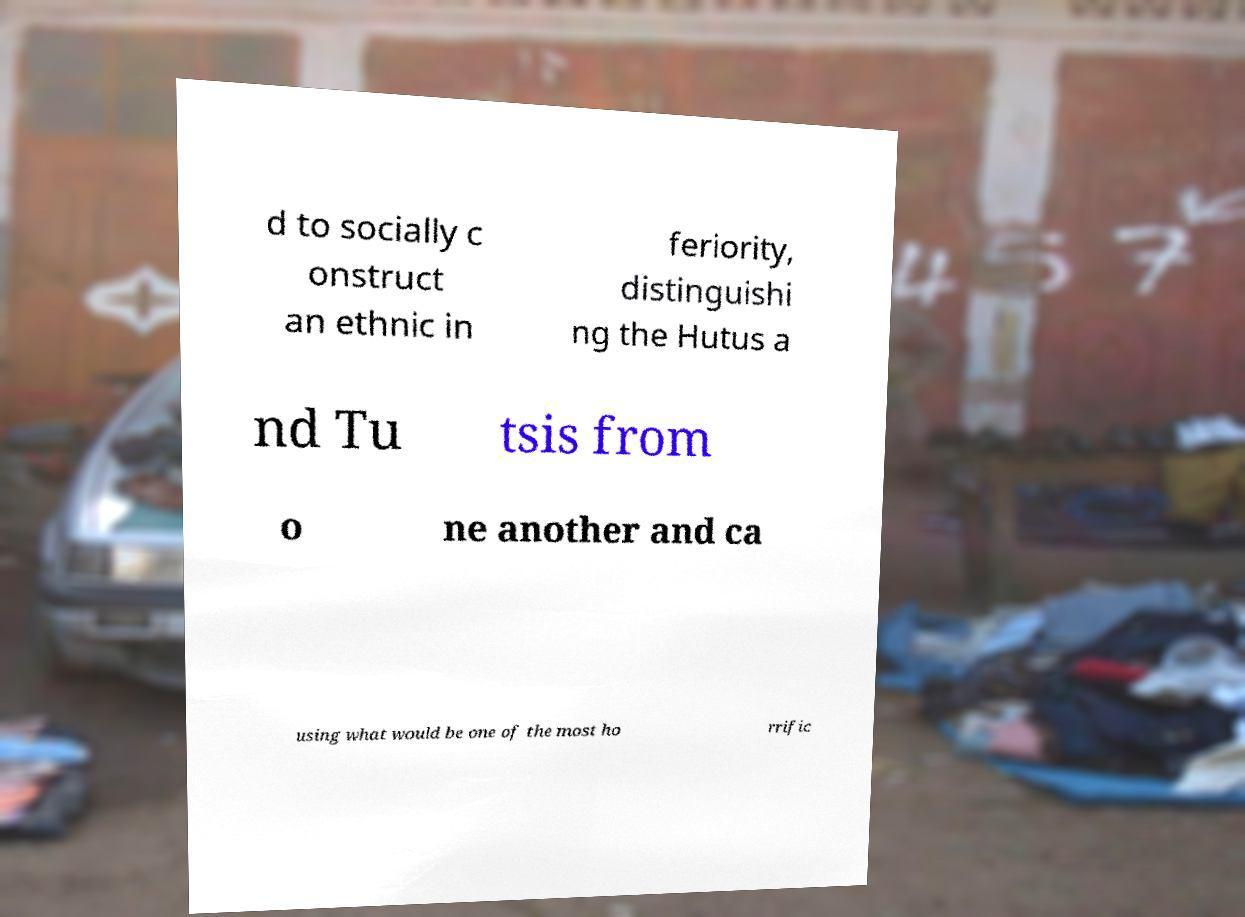Could you assist in decoding the text presented in this image and type it out clearly? d to socially c onstruct an ethnic in feriority, distinguishi ng the Hutus a nd Tu tsis from o ne another and ca using what would be one of the most ho rrific 